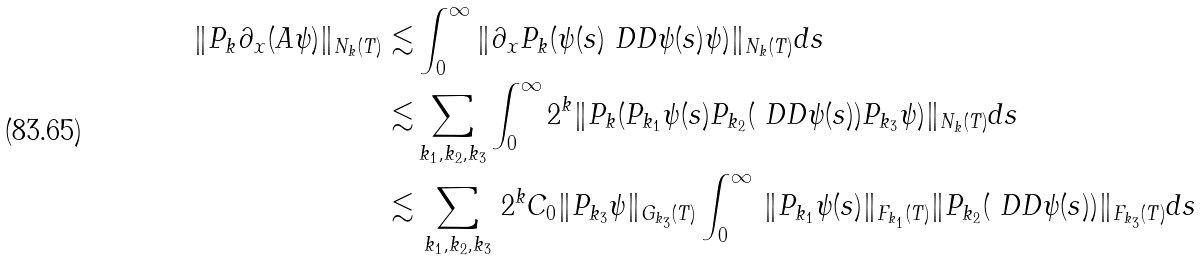Convert formula to latex. <formula><loc_0><loc_0><loc_500><loc_500>\| P _ { k } \partial _ { x } ( A \psi ) \| _ { N _ { k } ( T ) } \lesssim & \int _ { 0 } ^ { \infty } \| \partial _ { x } P _ { k } ( \psi ( s ) \ D D \psi ( s ) \psi ) \| _ { N _ { k } ( T ) } d s \\ \lesssim & \sum _ { k _ { 1 } , k _ { 2 } , k _ { 3 } } \int _ { 0 } ^ { \infty } 2 ^ { k } \| P _ { k } ( P _ { k _ { 1 } } \psi ( s ) P _ { k _ { 2 } } ( \ D D \psi ( s ) ) P _ { k _ { 3 } } \psi ) \| _ { N _ { k } ( T ) } d s \\ \lesssim & \, \sum _ { k _ { 1 } , k _ { 2 } , k _ { 3 } } \, 2 ^ { k } C _ { 0 } \| P _ { k _ { 3 } } \psi \| _ { G _ { k _ { 3 } } ( T ) } \int _ { 0 } ^ { \infty } \, \| P _ { k _ { 1 } } \psi ( s ) \| _ { F _ { k _ { 1 } } ( T ) } \| P _ { k _ { 2 } } ( \ D D \psi ( s ) ) \| _ { F _ { k _ { 3 } } ( T ) } d s</formula> 